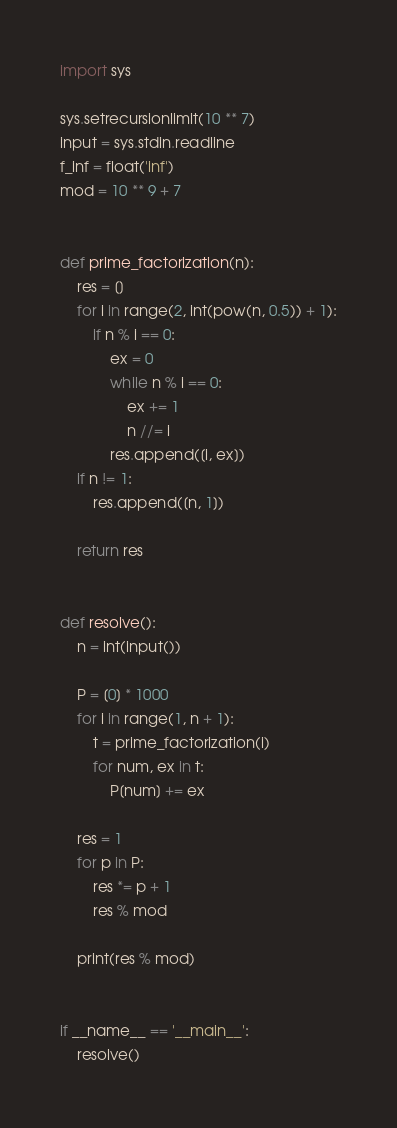<code> <loc_0><loc_0><loc_500><loc_500><_Python_>import sys

sys.setrecursionlimit(10 ** 7)
input = sys.stdin.readline
f_inf = float('inf')
mod = 10 ** 9 + 7


def prime_factorization(n):
    res = []
    for i in range(2, int(pow(n, 0.5)) + 1):
        if n % i == 0:
            ex = 0
            while n % i == 0:
                ex += 1
                n //= i
            res.append([i, ex])
    if n != 1:
        res.append([n, 1])

    return res


def resolve():
    n = int(input())

    P = [0] * 1000
    for i in range(1, n + 1):
        t = prime_factorization(i)
        for num, ex in t:
            P[num] += ex

    res = 1
    for p in P:
        res *= p + 1
        res % mod

    print(res % mod)


if __name__ == '__main__':
    resolve()
</code> 